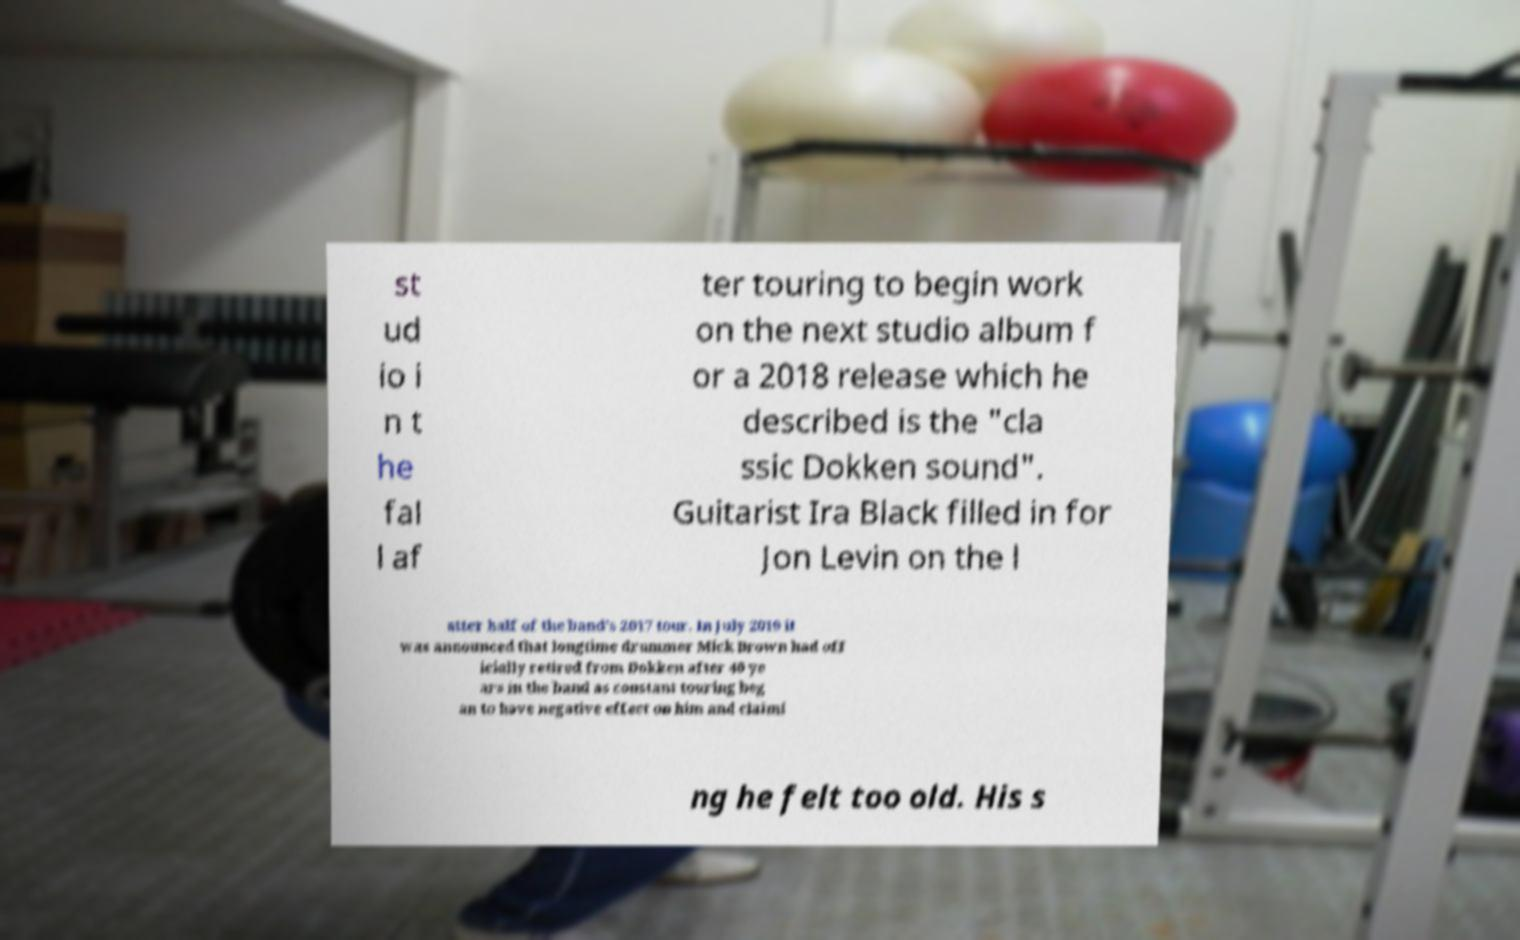For documentation purposes, I need the text within this image transcribed. Could you provide that? st ud io i n t he fal l af ter touring to begin work on the next studio album f or a 2018 release which he described is the "cla ssic Dokken sound". Guitarist Ira Black filled in for Jon Levin on the l atter half of the band's 2017 tour. In July 2019 it was announced that longtime drummer Mick Brown had off icially retired from Dokken after 40 ye ars in the band as constant touring beg an to have negative effect on him and claimi ng he felt too old. His s 